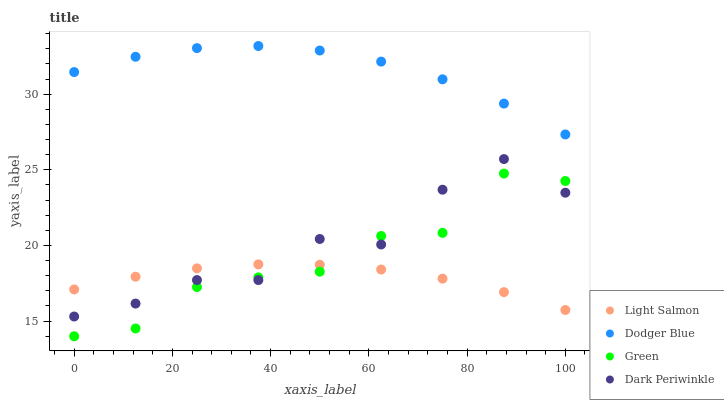Does Light Salmon have the minimum area under the curve?
Answer yes or no. Yes. Does Dodger Blue have the maximum area under the curve?
Answer yes or no. Yes. Does Dodger Blue have the minimum area under the curve?
Answer yes or no. No. Does Light Salmon have the maximum area under the curve?
Answer yes or no. No. Is Light Salmon the smoothest?
Answer yes or no. Yes. Is Dark Periwinkle the roughest?
Answer yes or no. Yes. Is Dodger Blue the smoothest?
Answer yes or no. No. Is Dodger Blue the roughest?
Answer yes or no. No. Does Green have the lowest value?
Answer yes or no. Yes. Does Light Salmon have the lowest value?
Answer yes or no. No. Does Dodger Blue have the highest value?
Answer yes or no. Yes. Does Light Salmon have the highest value?
Answer yes or no. No. Is Dark Periwinkle less than Dodger Blue?
Answer yes or no. Yes. Is Dodger Blue greater than Dark Periwinkle?
Answer yes or no. Yes. Does Dark Periwinkle intersect Green?
Answer yes or no. Yes. Is Dark Periwinkle less than Green?
Answer yes or no. No. Is Dark Periwinkle greater than Green?
Answer yes or no. No. Does Dark Periwinkle intersect Dodger Blue?
Answer yes or no. No. 